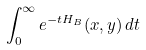Convert formula to latex. <formula><loc_0><loc_0><loc_500><loc_500>\int _ { 0 } ^ { \infty } e ^ { - t H _ { B } } ( x , y ) \, d t</formula> 